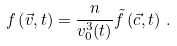<formula> <loc_0><loc_0><loc_500><loc_500>f \left ( \vec { v } , t \right ) = \frac { n } { v _ { 0 } ^ { 3 } ( t ) } \tilde { f } \left ( \vec { c } , t \right ) \, .</formula> 